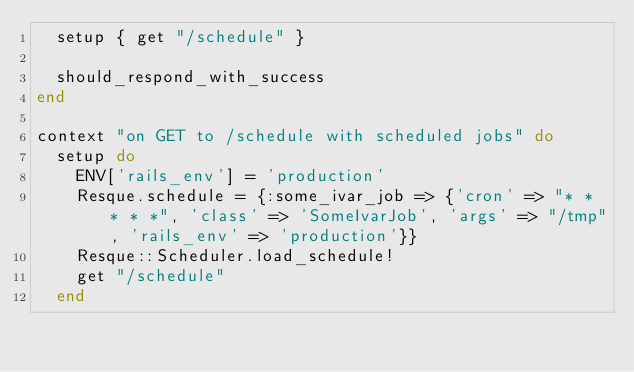<code> <loc_0><loc_0><loc_500><loc_500><_Ruby_>  setup { get "/schedule" }

  should_respond_with_success
end

context "on GET to /schedule with scheduled jobs" do
  setup do 
    ENV['rails_env'] = 'production'
    Resque.schedule = {:some_ivar_job => {'cron' => "* * * * *", 'class' => 'SomeIvarJob', 'args' => "/tmp", 'rails_env' => 'production'}}
    Resque::Scheduler.load_schedule!
    get "/schedule"
  end
</code> 